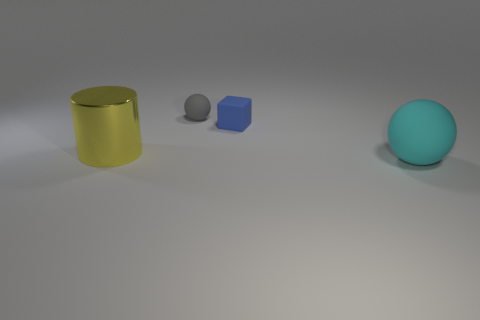Add 2 small red metal things. How many objects exist? 6 Subtract all gray spheres. How many spheres are left? 1 Subtract all cubes. How many objects are left? 3 Subtract all blue cubes. How many cyan balls are left? 1 Subtract 1 blocks. How many blocks are left? 0 Subtract all brown cylinders. Subtract all yellow blocks. How many cylinders are left? 1 Subtract all large metal objects. Subtract all small balls. How many objects are left? 2 Add 2 cyan matte things. How many cyan matte things are left? 3 Add 2 green rubber cubes. How many green rubber cubes exist? 2 Subtract 0 green cylinders. How many objects are left? 4 